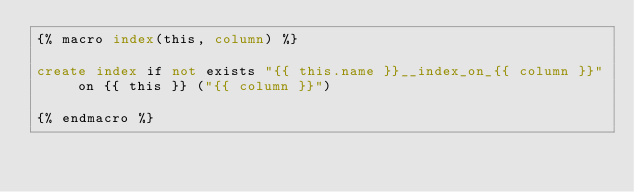<code> <loc_0><loc_0><loc_500><loc_500><_SQL_>{% macro index(this, column) %}

create index if not exists "{{ this.name }}__index_on_{{ column }}" on {{ this }} ("{{ column }}")

{% endmacro %}
</code> 